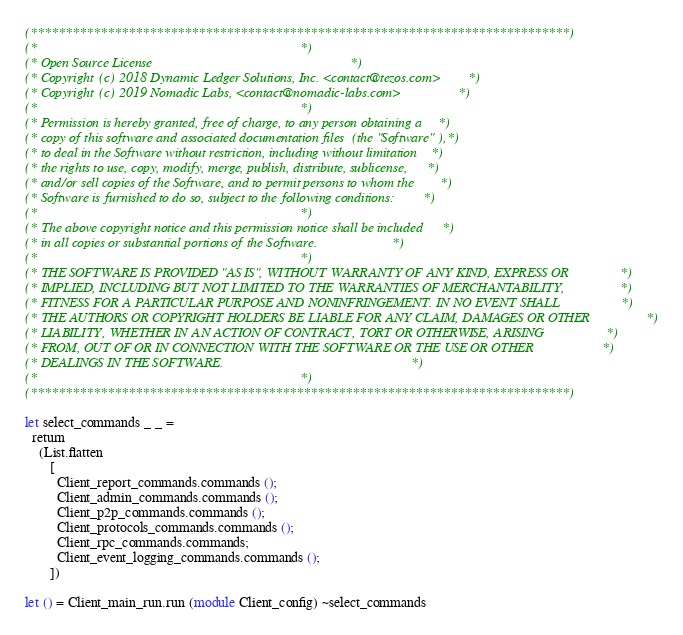Convert code to text. <code><loc_0><loc_0><loc_500><loc_500><_OCaml_>(*****************************************************************************)
(*                                                                           *)
(* Open Source License                                                       *)
(* Copyright (c) 2018 Dynamic Ledger Solutions, Inc. <contact@tezos.com>     *)
(* Copyright (c) 2019 Nomadic Labs, <contact@nomadic-labs.com>               *)
(*                                                                           *)
(* Permission is hereby granted, free of charge, to any person obtaining a   *)
(* copy of this software and associated documentation files (the "Software"),*)
(* to deal in the Software without restriction, including without limitation *)
(* the rights to use, copy, modify, merge, publish, distribute, sublicense,  *)
(* and/or sell copies of the Software, and to permit persons to whom the     *)
(* Software is furnished to do so, subject to the following conditions:      *)
(*                                                                           *)
(* The above copyright notice and this permission notice shall be included   *)
(* in all copies or substantial portions of the Software.                    *)
(*                                                                           *)
(* THE SOFTWARE IS PROVIDED "AS IS", WITHOUT WARRANTY OF ANY KIND, EXPRESS OR*)
(* IMPLIED, INCLUDING BUT NOT LIMITED TO THE WARRANTIES OF MERCHANTABILITY,  *)
(* FITNESS FOR A PARTICULAR PURPOSE AND NONINFRINGEMENT. IN NO EVENT SHALL   *)
(* THE AUTHORS OR COPYRIGHT HOLDERS BE LIABLE FOR ANY CLAIM, DAMAGES OR OTHER*)
(* LIABILITY, WHETHER IN AN ACTION OF CONTRACT, TORT OR OTHERWISE, ARISING   *)
(* FROM, OUT OF OR IN CONNECTION WITH THE SOFTWARE OR THE USE OR OTHER       *)
(* DEALINGS IN THE SOFTWARE.                                                 *)
(*                                                                           *)
(*****************************************************************************)

let select_commands _ _ =
  return
    (List.flatten
       [
         Client_report_commands.commands ();
         Client_admin_commands.commands ();
         Client_p2p_commands.commands ();
         Client_protocols_commands.commands ();
         Client_rpc_commands.commands;
         Client_event_logging_commands.commands ();
       ])

let () = Client_main_run.run (module Client_config) ~select_commands
</code> 